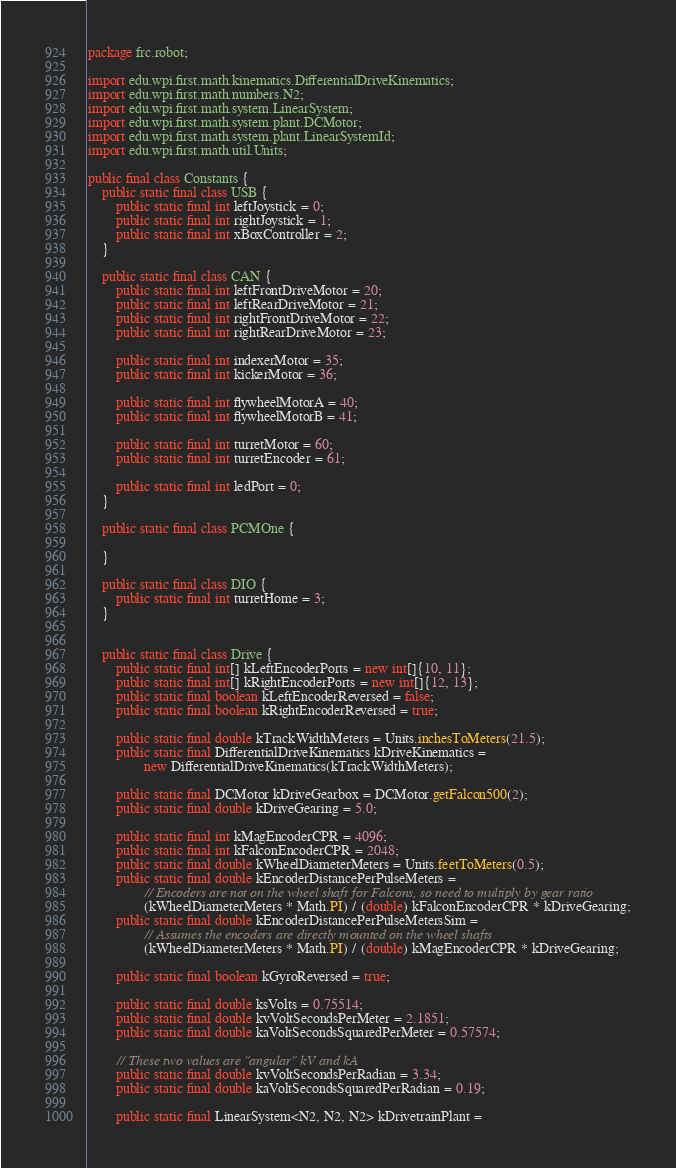<code> <loc_0><loc_0><loc_500><loc_500><_Java_>package frc.robot;

import edu.wpi.first.math.kinematics.DifferentialDriveKinematics;
import edu.wpi.first.math.numbers.N2;
import edu.wpi.first.math.system.LinearSystem;
import edu.wpi.first.math.system.plant.DCMotor;
import edu.wpi.first.math.system.plant.LinearSystemId;
import edu.wpi.first.math.util.Units;

public final class Constants {
    public static final class USB {
        public static final int leftJoystick = 0;
        public static final int rightJoystick = 1;
        public static final int xBoxController = 2;    
    }

    public static final class CAN {
        public static final int leftFrontDriveMotor = 20;
        public static final int leftRearDriveMotor = 21;
        public static final int rightFrontDriveMotor = 22;
        public static final int rightRearDriveMotor = 23;

        public static final int indexerMotor = 35;
        public static final int kickerMotor = 36;

        public static final int flywheelMotorA = 40;
        public static final int flywheelMotorB = 41;

        public static final int turretMotor = 60;
        public static final int turretEncoder = 61;

        public static final int ledPort = 0;
    }

    public static final class PCMOne {

    }

    public static final class DIO {
        public static final int turretHome = 3;
    }


    public static final class Drive {
        public static final int[] kLeftEncoderPorts = new int[]{10, 11};
        public static final int[] kRightEncoderPorts = new int[]{12, 13};
        public static final boolean kLeftEncoderReversed = false;
        public static final boolean kRightEncoderReversed = true;

        public static final double kTrackWidthMeters = Units.inchesToMeters(21.5);
        public static final DifferentialDriveKinematics kDriveKinematics =
                new DifferentialDriveKinematics(kTrackWidthMeters);

        public static final DCMotor kDriveGearbox = DCMotor.getFalcon500(2);
        public static final double kDriveGearing = 5.0;

        public static final int kMagEncoderCPR = 4096;
        public static final int kFalconEncoderCPR = 2048;
        public static final double kWheelDiameterMeters = Units.feetToMeters(0.5);
        public static final double kEncoderDistancePerPulseMeters =
                // Encoders are not on the wheel shaft for Falcons, so need to multiply by gear ratio
                (kWheelDiameterMeters * Math.PI) / (double) kFalconEncoderCPR * kDriveGearing;
        public static final double kEncoderDistancePerPulseMetersSim =
                // Assumes the encoders are directly mounted on the wheel shafts
                (kWheelDiameterMeters * Math.PI) / (double) kMagEncoderCPR * kDriveGearing;

        public static final boolean kGyroReversed = true;

        public static final double ksVolts = 0.75514;
        public static final double kvVoltSecondsPerMeter = 2.1851;
        public static final double kaVoltSecondsSquaredPerMeter = 0.57574;

        // These two values are "angular" kV and kA
        public static final double kvVoltSecondsPerRadian = 3.34;
        public static final double kaVoltSecondsSquaredPerRadian = 0.19;

        public static final LinearSystem<N2, N2, N2> kDrivetrainPlant =</code> 